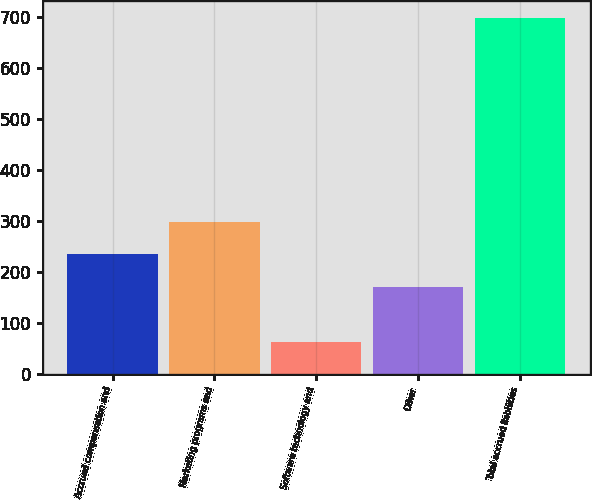<chart> <loc_0><loc_0><loc_500><loc_500><bar_chart><fcel>Accrued compensation and<fcel>Marketing programs and<fcel>Software technology and<fcel>Other<fcel>Total accrued liabilities<nl><fcel>235.5<fcel>299<fcel>63<fcel>172<fcel>698<nl></chart> 